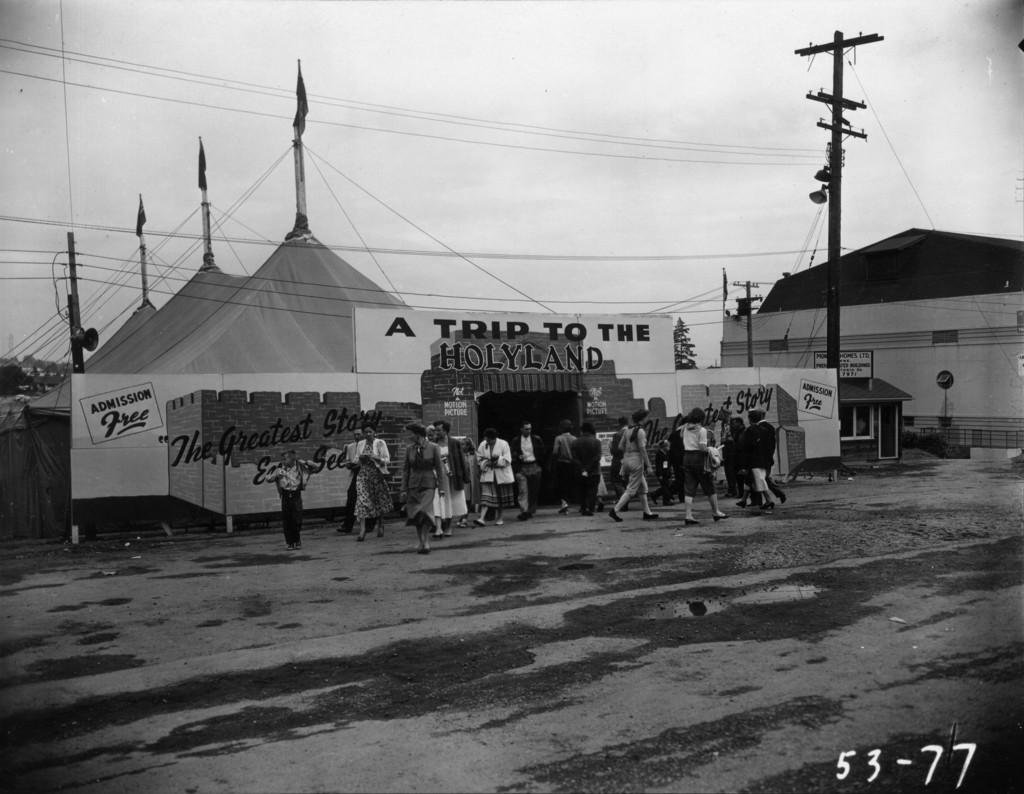Please provide a concise description of this image. In this image we can see the people standing. And we can see the tents, electric poles and cables. We can see the boards with some text on it. At the top we can see the sky. 